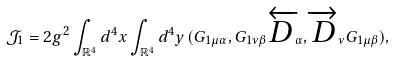<formula> <loc_0><loc_0><loc_500><loc_500>\mathcal { J } _ { 1 } = 2 g ^ { 2 } \int _ { \mathbb { R } ^ { 4 } } d ^ { 4 } x \int _ { \mathbb { R } ^ { 4 } } d ^ { 4 } y \, ( G _ { 1 \mu \alpha } , G _ { 1 \nu \beta } \overleftarrow { D } _ { \alpha } , \overrightarrow { D } _ { \nu } G _ { 1 \mu \beta } ) ,</formula> 